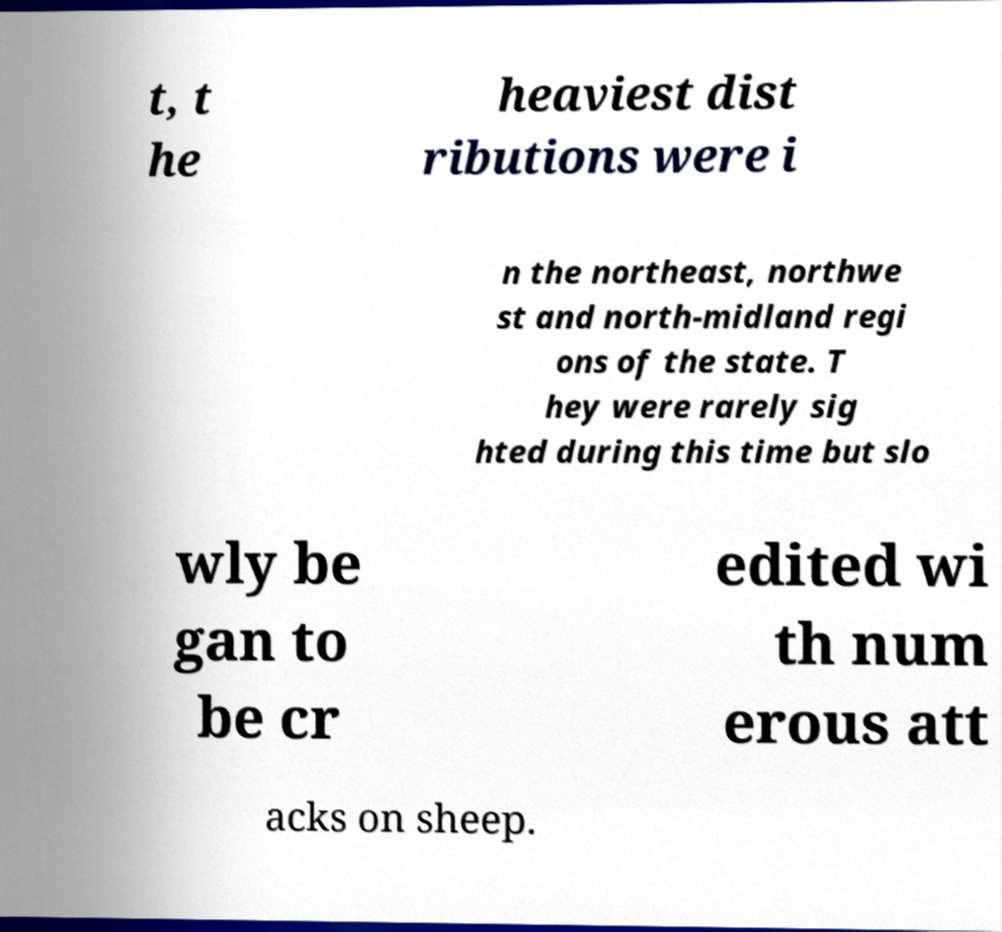Could you extract and type out the text from this image? t, t he heaviest dist ributions were i n the northeast, northwe st and north-midland regi ons of the state. T hey were rarely sig hted during this time but slo wly be gan to be cr edited wi th num erous att acks on sheep. 